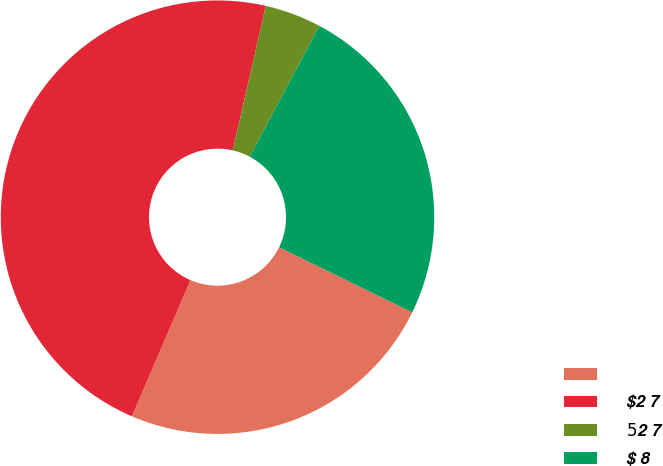<chart> <loc_0><loc_0><loc_500><loc_500><pie_chart><ecel><fcel>$2 7<fcel>$5 $2 7<fcel>$ 8<nl><fcel>24.22%<fcel>47.12%<fcel>4.21%<fcel>24.45%<nl></chart> 